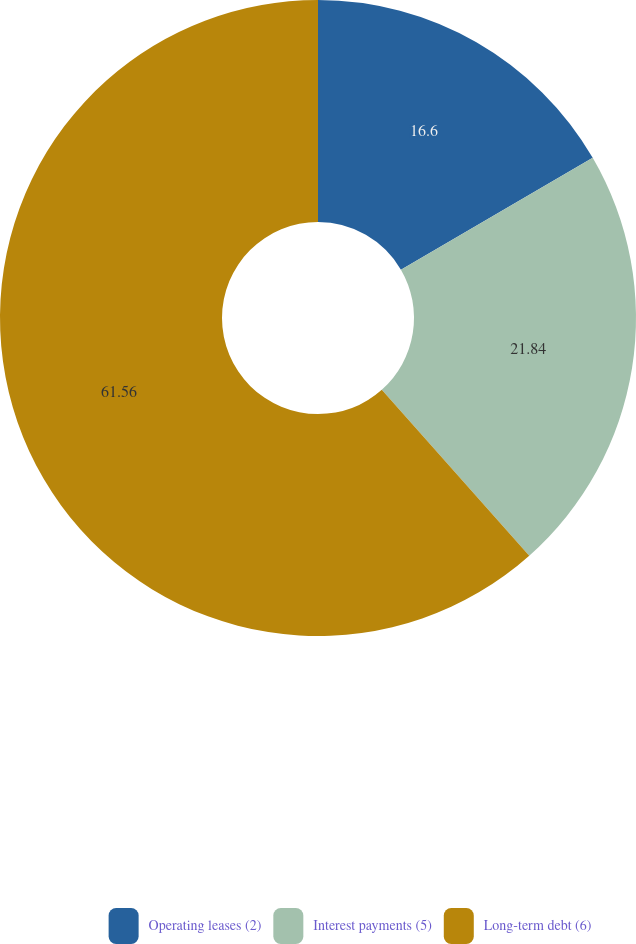Convert chart to OTSL. <chart><loc_0><loc_0><loc_500><loc_500><pie_chart><fcel>Operating leases (2)<fcel>Interest payments (5)<fcel>Long-term debt (6)<nl><fcel>16.6%<fcel>21.84%<fcel>61.57%<nl></chart> 